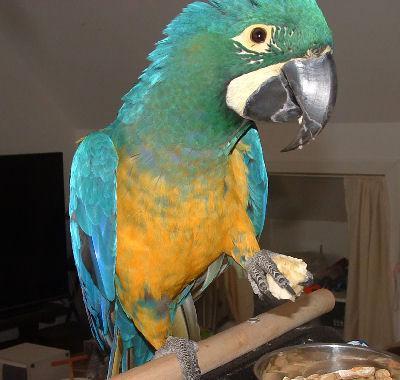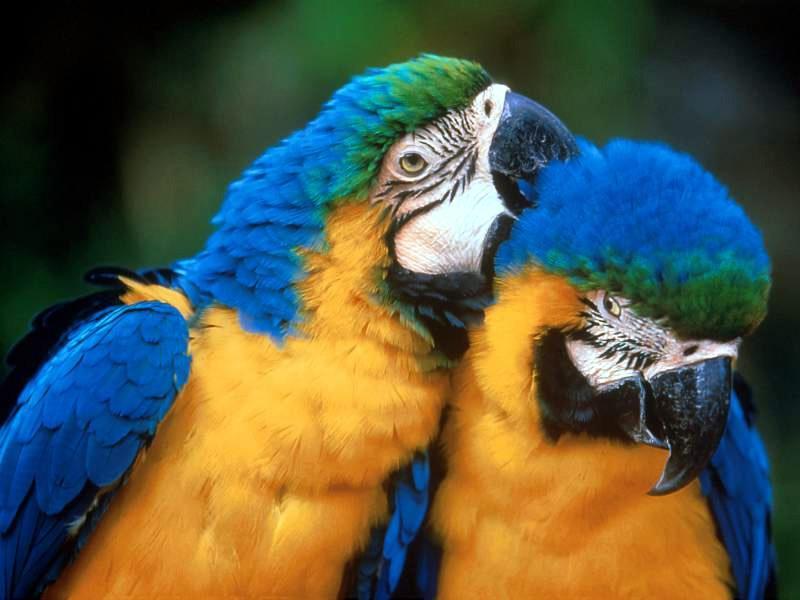The first image is the image on the left, the second image is the image on the right. Examine the images to the left and right. Is the description "One of the images has only two parrots." accurate? Answer yes or no. Yes. The first image is the image on the left, the second image is the image on the right. Assess this claim about the two images: "There are at least 2 blue-headed parrots.". Correct or not? Answer yes or no. Yes. 